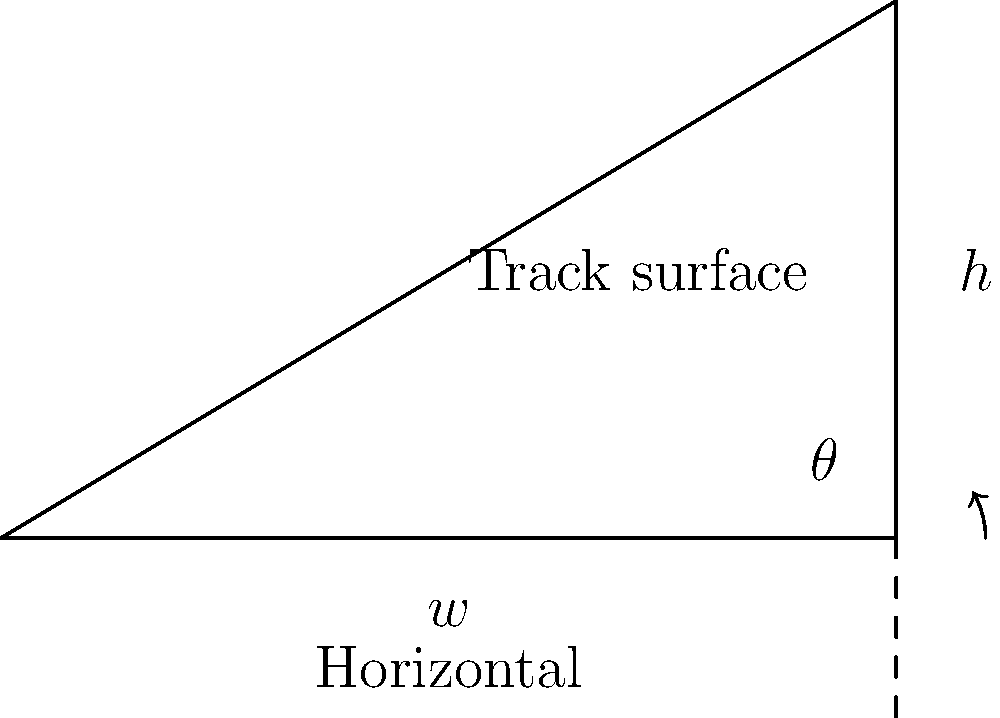At Talladega Superspeedway, one of the turns has a banking angle of 33°. If the width of the track is 58 feet, what is the height difference between the inside and outside edges of the track? Round your answer to the nearest foot. To solve this problem, we'll use trigonometry. Let's break it down step-by-step:

1) In a right-angled triangle formed by the track's cross-section:
   - The angle of banking is $\theta = 33°$
   - The width of the track is the base of the triangle, $w = 58$ feet
   - We need to find the height $h$

2) We can use the tangent function to relate these:

   $\tan \theta = \frac{\text{opposite}}{\text{adjacent}} = \frac{h}{w}$

3) Rearranging this equation:

   $h = w \times \tan \theta$

4) Plugging in our values:

   $h = 58 \times \tan 33°$

5) Using a calculator (or trigonometric tables):

   $\tan 33° \approx 0.6494$

6) Therefore:

   $h = 58 \times 0.6494 \approx 37.6652$ feet

7) Rounding to the nearest foot:

   $h \approx 38$ feet
Answer: 38 feet 